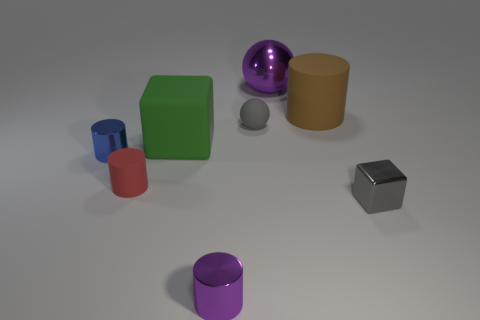Subtract all blue cylinders. How many cylinders are left? 3 Subtract all green cubes. How many cubes are left? 1 Subtract all cubes. How many objects are left? 6 Subtract 3 cylinders. How many cylinders are left? 1 Subtract all gray balls. Subtract all purple blocks. How many balls are left? 1 Subtract all gray blocks. How many gray balls are left? 1 Subtract all big yellow metallic things. Subtract all big cubes. How many objects are left? 7 Add 7 purple cylinders. How many purple cylinders are left? 8 Add 3 large cylinders. How many large cylinders exist? 4 Add 1 cyan balls. How many objects exist? 9 